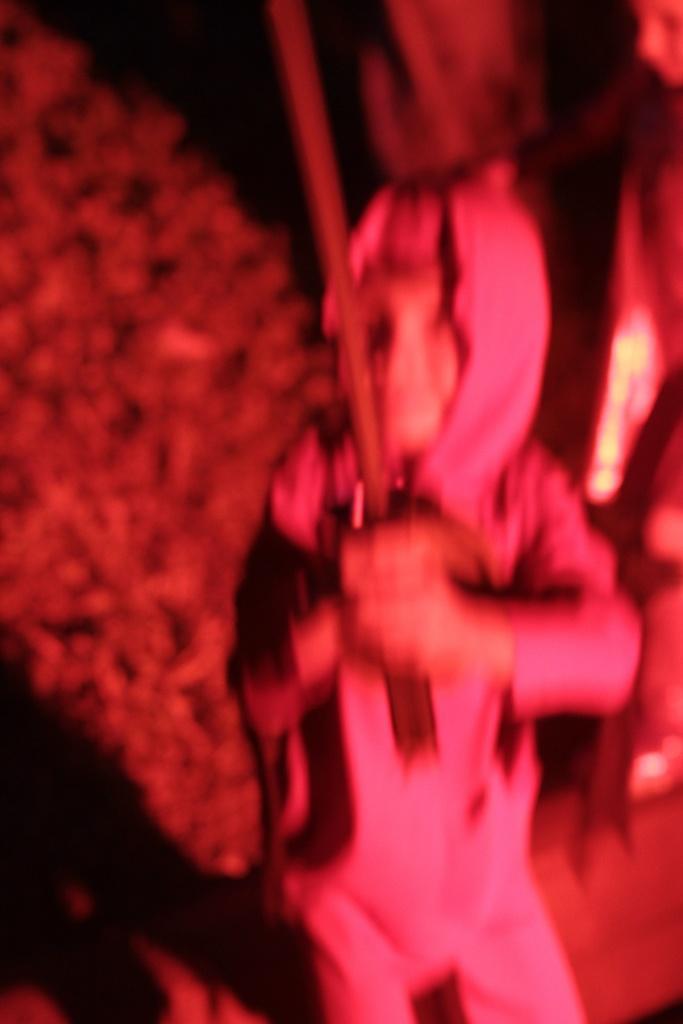Can you describe this image briefly? In this image there is a person holding a stick. And at the background there is a blur image. 